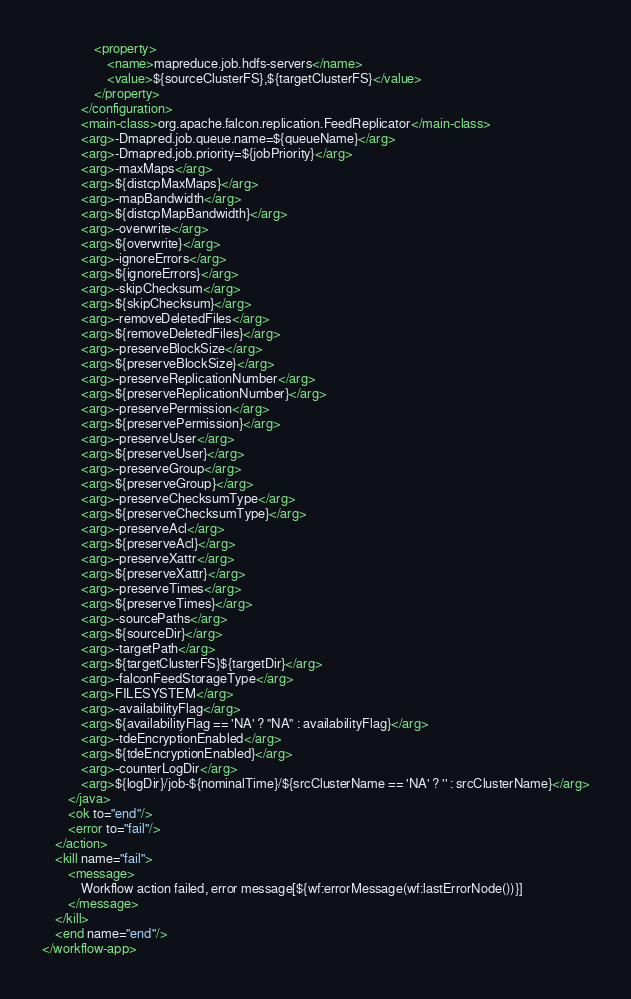<code> <loc_0><loc_0><loc_500><loc_500><_XML_>                <property>
                    <name>mapreduce.job.hdfs-servers</name>
                    <value>${sourceClusterFS},${targetClusterFS}</value>
                </property>
            </configuration>
            <main-class>org.apache.falcon.replication.FeedReplicator</main-class>
            <arg>-Dmapred.job.queue.name=${queueName}</arg>
            <arg>-Dmapred.job.priority=${jobPriority}</arg>
            <arg>-maxMaps</arg>
            <arg>${distcpMaxMaps}</arg>
            <arg>-mapBandwidth</arg>
            <arg>${distcpMapBandwidth}</arg>
            <arg>-overwrite</arg>
            <arg>${overwrite}</arg>
            <arg>-ignoreErrors</arg>
            <arg>${ignoreErrors}</arg>
            <arg>-skipChecksum</arg>
            <arg>${skipChecksum}</arg>
            <arg>-removeDeletedFiles</arg>
            <arg>${removeDeletedFiles}</arg>
            <arg>-preserveBlockSize</arg>
            <arg>${preserveBlockSize}</arg>
            <arg>-preserveReplicationNumber</arg>
            <arg>${preserveReplicationNumber}</arg>
            <arg>-preservePermission</arg>
            <arg>${preservePermission}</arg>
            <arg>-preserveUser</arg>
            <arg>${preserveUser}</arg>
            <arg>-preserveGroup</arg>
            <arg>${preserveGroup}</arg>
            <arg>-preserveChecksumType</arg>
            <arg>${preserveChecksumType}</arg>
            <arg>-preserveAcl</arg>
            <arg>${preserveAcl}</arg>
            <arg>-preserveXattr</arg>
            <arg>${preserveXattr}</arg>
            <arg>-preserveTimes</arg>
            <arg>${preserveTimes}</arg>
            <arg>-sourcePaths</arg>
            <arg>${sourceDir}</arg>
            <arg>-targetPath</arg>
            <arg>${targetClusterFS}${targetDir}</arg>
            <arg>-falconFeedStorageType</arg>
            <arg>FILESYSTEM</arg>
            <arg>-availabilityFlag</arg>
            <arg>${availabilityFlag == 'NA' ? "NA" : availabilityFlag}</arg>
            <arg>-tdeEncryptionEnabled</arg>
            <arg>${tdeEncryptionEnabled}</arg>
            <arg>-counterLogDir</arg>
            <arg>${logDir}/job-${nominalTime}/${srcClusterName == 'NA' ? '' : srcClusterName}</arg>
        </java>
        <ok to="end"/>
        <error to="fail"/>
    </action>
    <kill name="fail">
        <message>
            Workflow action failed, error message[${wf:errorMessage(wf:lastErrorNode())}]
        </message>
    </kill>
    <end name="end"/>
</workflow-app>
</code> 